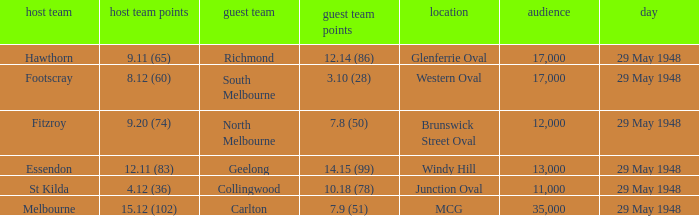Would you mind parsing the complete table? {'header': ['host team', 'host team points', 'guest team', 'guest team points', 'location', 'audience', 'day'], 'rows': [['Hawthorn', '9.11 (65)', 'Richmond', '12.14 (86)', 'Glenferrie Oval', '17,000', '29 May 1948'], ['Footscray', '8.12 (60)', 'South Melbourne', '3.10 (28)', 'Western Oval', '17,000', '29 May 1948'], ['Fitzroy', '9.20 (74)', 'North Melbourne', '7.8 (50)', 'Brunswick Street Oval', '12,000', '29 May 1948'], ['Essendon', '12.11 (83)', 'Geelong', '14.15 (99)', 'Windy Hill', '13,000', '29 May 1948'], ['St Kilda', '4.12 (36)', 'Collingwood', '10.18 (78)', 'Junction Oval', '11,000', '29 May 1948'], ['Melbourne', '15.12 (102)', 'Carlton', '7.9 (51)', 'MCG', '35,000', '29 May 1948']]} In the match where footscray was the home team, how much did they score? 8.12 (60). 